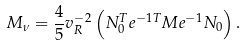Convert formula to latex. <formula><loc_0><loc_0><loc_500><loc_500>M _ { \nu } = \frac { 4 } { 5 } v _ { R } ^ { - 2 } \left ( N _ { 0 } ^ { T } e ^ { - 1 T } M e ^ { - 1 } N _ { 0 } \right ) .</formula> 